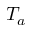<formula> <loc_0><loc_0><loc_500><loc_500>T _ { a }</formula> 